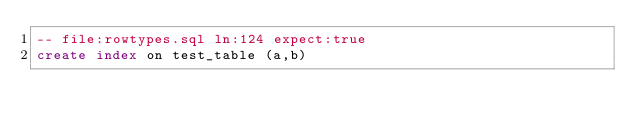<code> <loc_0><loc_0><loc_500><loc_500><_SQL_>-- file:rowtypes.sql ln:124 expect:true
create index on test_table (a,b)
</code> 